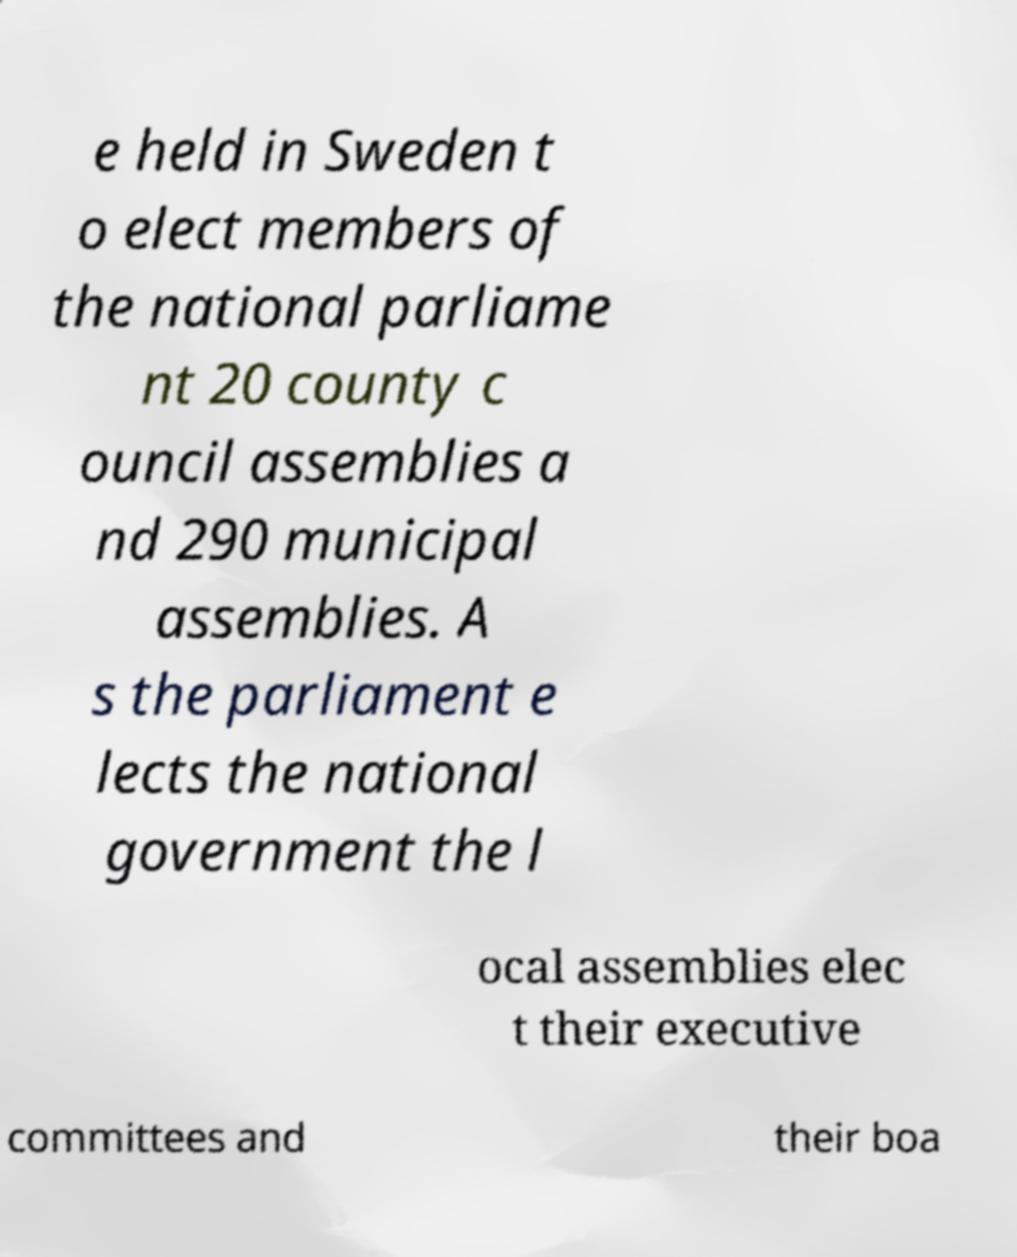There's text embedded in this image that I need extracted. Can you transcribe it verbatim? e held in Sweden t o elect members of the national parliame nt 20 county c ouncil assemblies a nd 290 municipal assemblies. A s the parliament e lects the national government the l ocal assemblies elec t their executive committees and their boa 